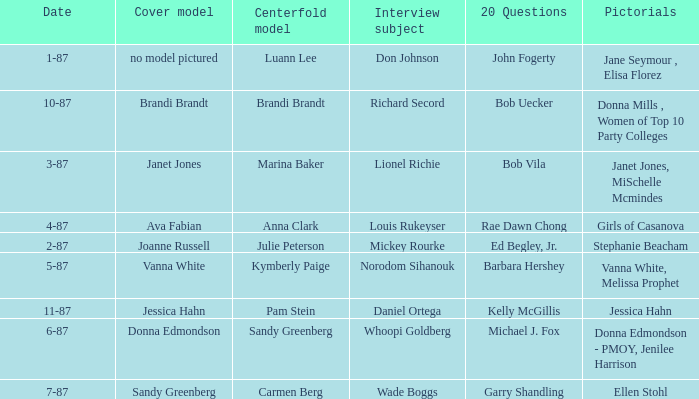When was the Kymberly Paige the Centerfold? 5-87. 